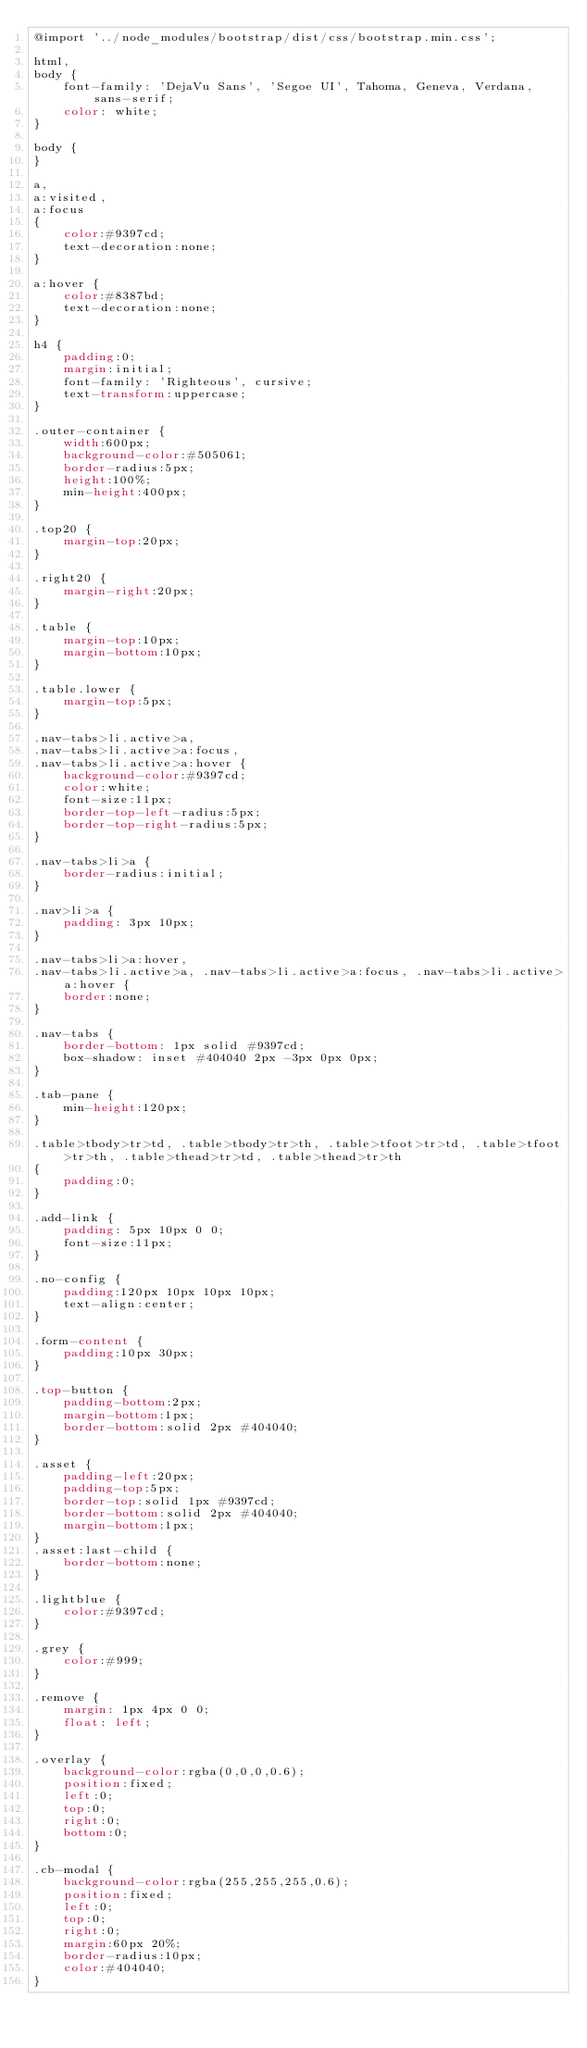Convert code to text. <code><loc_0><loc_0><loc_500><loc_500><_CSS_>@import '../node_modules/bootstrap/dist/css/bootstrap.min.css';

html,
body {
    font-family: 'DejaVu Sans', 'Segoe UI', Tahoma, Geneva, Verdana, sans-serif;
    color: white;
}

body {
}

a,
a:visited,
a:focus
{
    color:#9397cd;
    text-decoration:none;
}

a:hover {
    color:#8387bd;
    text-decoration:none;
}

h4 {
    padding:0;
    margin:initial;
    font-family: 'Righteous', cursive;
    text-transform:uppercase;
}

.outer-container {
    width:600px;
    background-color:#505061;
    border-radius:5px;
    height:100%;
    min-height:400px;
}

.top20 {
    margin-top:20px;
}

.right20 {
    margin-right:20px;
}

.table {
    margin-top:10px;
    margin-bottom:10px;
}

.table.lower {
    margin-top:5px;
}

.nav-tabs>li.active>a, 
.nav-tabs>li.active>a:focus, 
.nav-tabs>li.active>a:hover {
    background-color:#9397cd;
    color:white;
    font-size:11px;
    border-top-left-radius:5px;
    border-top-right-radius:5px;
}

.nav-tabs>li>a {
    border-radius:initial;
}

.nav>li>a {
    padding: 3px 10px;
}

.nav-tabs>li>a:hover,
.nav-tabs>li.active>a, .nav-tabs>li.active>a:focus, .nav-tabs>li.active>a:hover {
    border:none;
}

.nav-tabs {
    border-bottom: 1px solid #9397cd;
    box-shadow: inset #404040 2px -3px 0px 0px;
}

.tab-pane {
    min-height:120px;
}

.table>tbody>tr>td, .table>tbody>tr>th, .table>tfoot>tr>td, .table>tfoot>tr>th, .table>thead>tr>td, .table>thead>tr>th
{
    padding:0;
}

.add-link {
    padding: 5px 10px 0 0;
    font-size:11px;
}

.no-config {
    padding:120px 10px 10px 10px;
    text-align:center;
}

.form-content {
    padding:10px 30px;
}

.top-button {
    padding-bottom:2px;
    margin-bottom:1px;
    border-bottom:solid 2px #404040;
}

.asset {
    padding-left:20px;
    padding-top:5px;
    border-top:solid 1px #9397cd;
    border-bottom:solid 2px #404040;
    margin-bottom:1px;
}
.asset:last-child {
    border-bottom:none;
}

.lightblue {
    color:#9397cd;
}

.grey {
    color:#999;
}

.remove {
    margin: 1px 4px 0 0;
    float: left;
}

.overlay {
    background-color:rgba(0,0,0,0.6);
    position:fixed;
    left:0;
    top:0;
    right:0;
    bottom:0;
}

.cb-modal {
    background-color:rgba(255,255,255,0.6);
    position:fixed;
    left:0;
    top:0;
    right:0;
    margin:60px 20%;
    border-radius:10px;
    color:#404040;
}</code> 